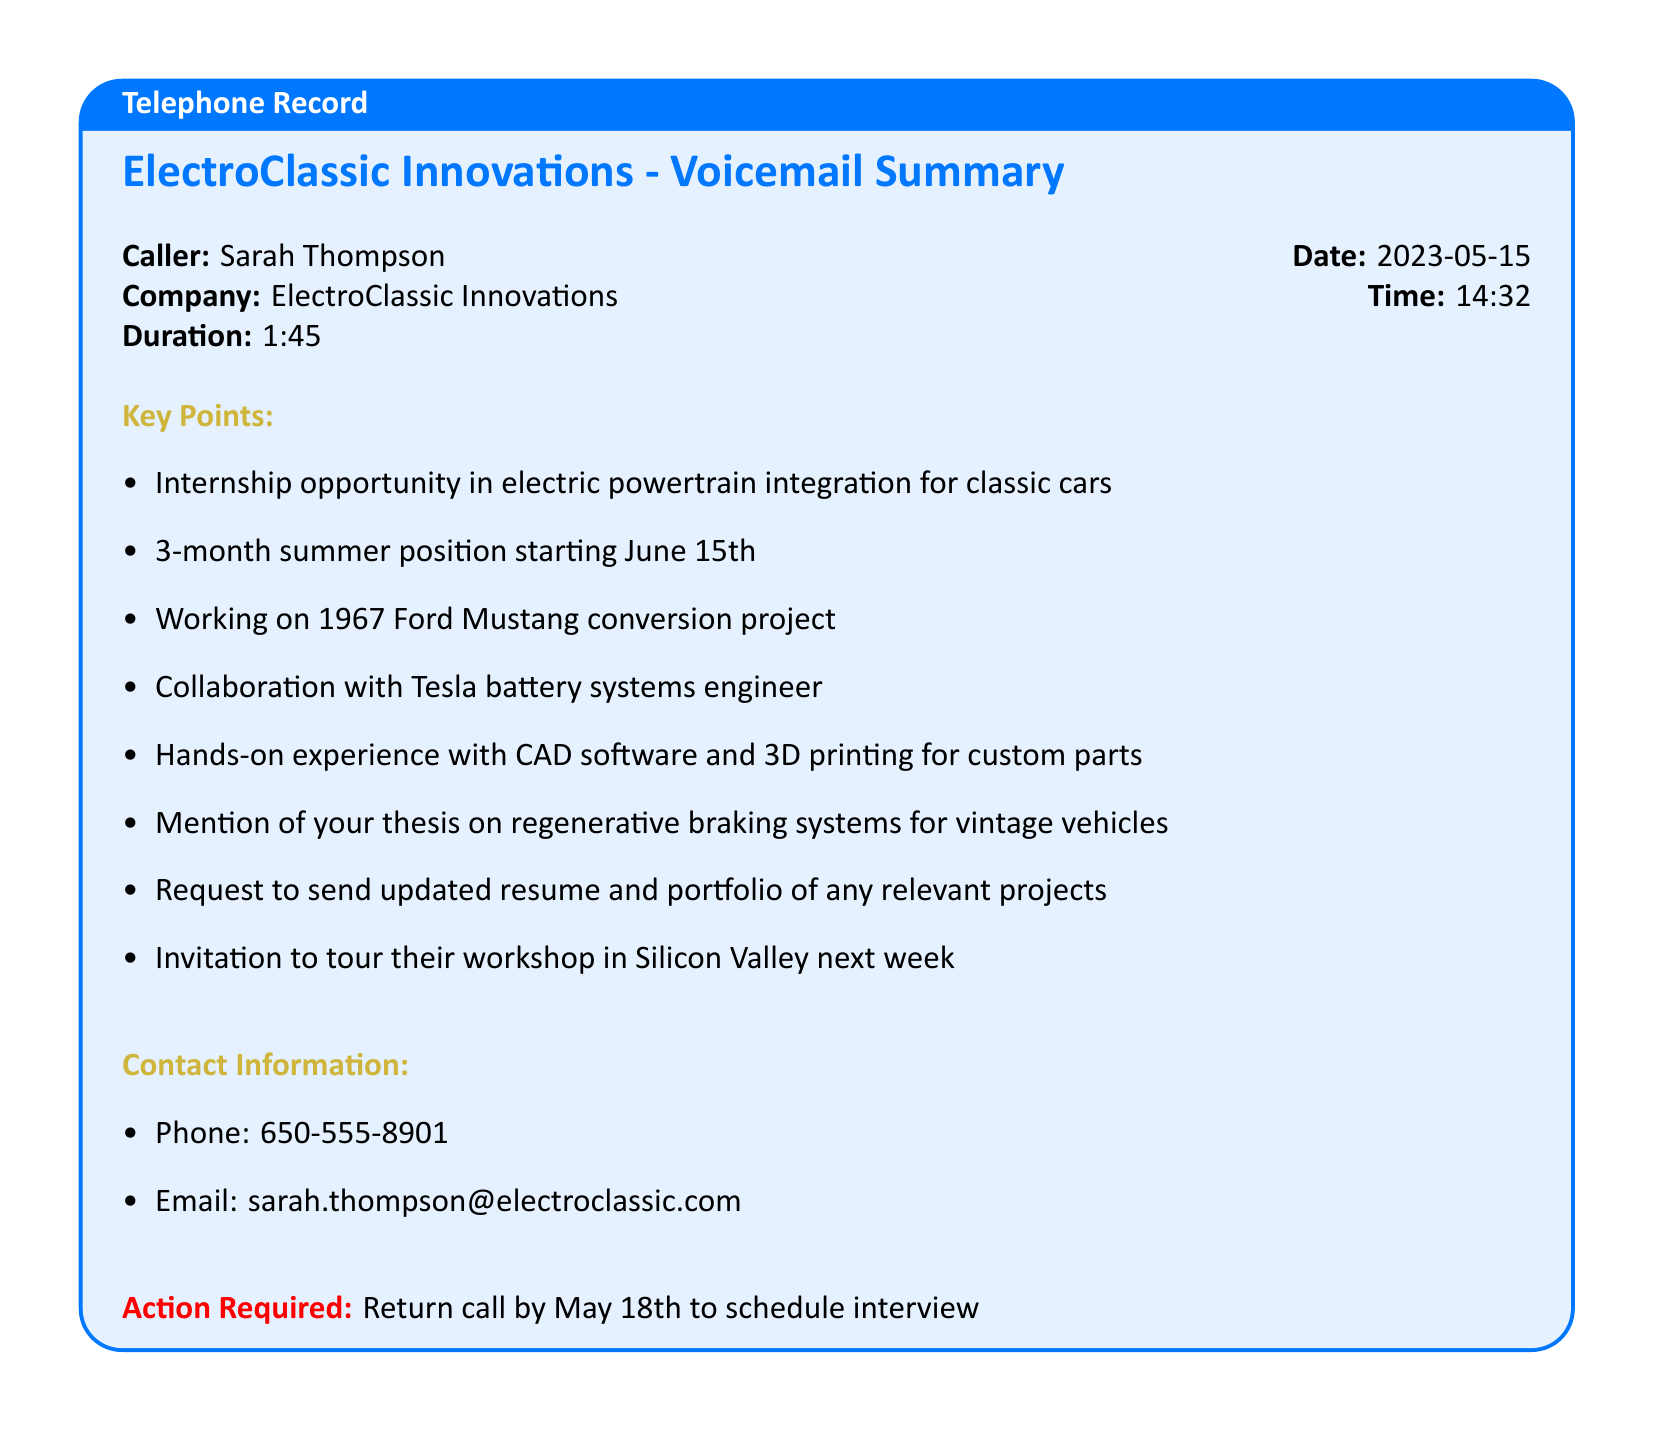what is the name of the caller? The name of the caller is specified in the document, which is Sarah Thompson.
Answer: Sarah Thompson what is the company name? The company name is directly mentioned in the voicemail summary, which is ElectroClassic Innovations.
Answer: ElectroClassic Innovations when does the internship start? The start date of the internship is provided in the document, which is June 15th.
Answer: June 15th how long is the internship? The duration of the internship is mentioned in the summary, which is a 3-month position.
Answer: 3-month what project will the intern work on? The specific project the intern will be working on is detailed in the document as the 1967 Ford Mustang conversion project.
Answer: 1967 Ford Mustang conversion project who will the intern collaborate with? The document states that the intern will collaborate with a Tesla battery systems engineer.
Answer: Tesla battery systems engineer what is the action required by the recipient? The action required is specified in the summary, which is to return the call.
Answer: Return call by what date should the call be returned? The date for returning the call is explicitly mentioned as May 18th.
Answer: May 18th what type of experiences will the intern gain? The document specifies the experiences as hands-on experience with CAD software and 3D printing.
Answer: CAD software and 3D printing 